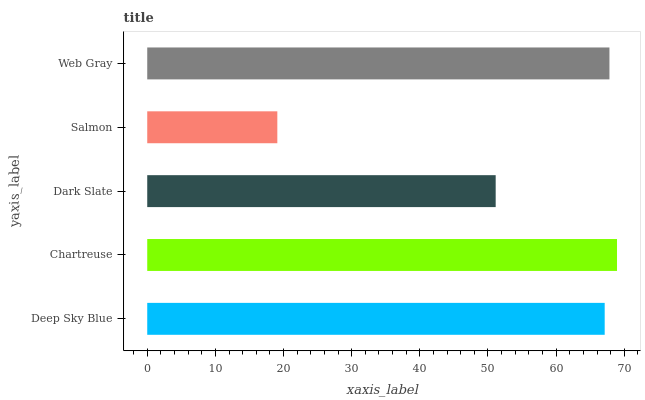Is Salmon the minimum?
Answer yes or no. Yes. Is Chartreuse the maximum?
Answer yes or no. Yes. Is Dark Slate the minimum?
Answer yes or no. No. Is Dark Slate the maximum?
Answer yes or no. No. Is Chartreuse greater than Dark Slate?
Answer yes or no. Yes. Is Dark Slate less than Chartreuse?
Answer yes or no. Yes. Is Dark Slate greater than Chartreuse?
Answer yes or no. No. Is Chartreuse less than Dark Slate?
Answer yes or no. No. Is Deep Sky Blue the high median?
Answer yes or no. Yes. Is Deep Sky Blue the low median?
Answer yes or no. Yes. Is Salmon the high median?
Answer yes or no. No. Is Web Gray the low median?
Answer yes or no. No. 